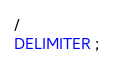Convert code to text. <code><loc_0><loc_0><loc_500><loc_500><_SQL_>/
DELIMITER ;
</code> 